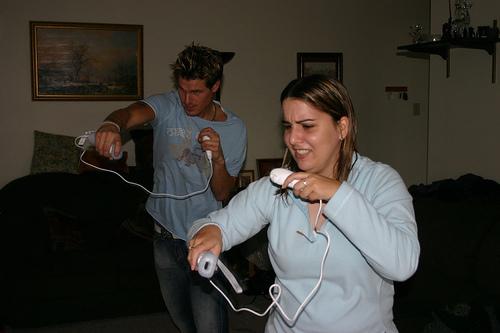What color is the remote?
Quick response, please. White. What color is the woman's outfit?
Quick response, please. Blue. Is the boy in blue looking at the camera?
Short answer required. No. What color is her shirt?
Quick response, please. Blue. What sport is being played?
Write a very short answer. Wii. Are they using the nunchucks?
Short answer required. No. Is the man wearing jeans?
Keep it brief. Yes. Are the ladies enjoying a game?
Write a very short answer. Yes. Is the woman's jacket black?
Answer briefly. No. What game are the people playing?
Give a very brief answer. Wii. What is this person smiling about?
Write a very short answer. Game. What color is the woman's shirt?
Concise answer only. Blue. How many people are there?
Concise answer only. 2. Is there a poster of  girl on the wall?
Keep it brief. No. How interested is the man?
Be succinct. Very. Does this show a wedding?
Concise answer only. No. Are the shirts they are wearing similar in color?
Quick response, please. Yes. What color is the man's shirt?
Concise answer only. Blue. What does the woman on the right have on her head?
Be succinct. Hair. What color is the couch?
Quick response, please. Black. Which direction is this woman's face facing?
Answer briefly. Left. 